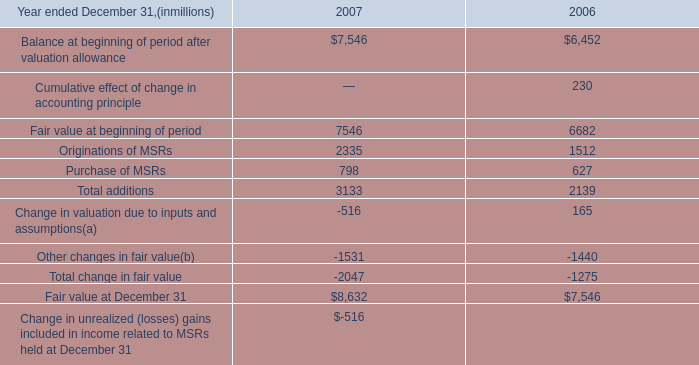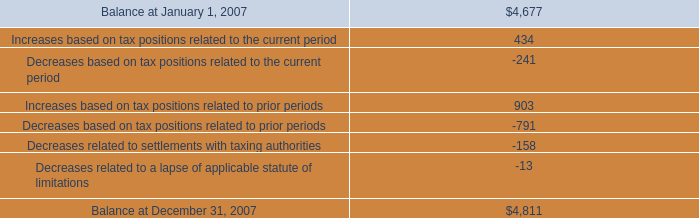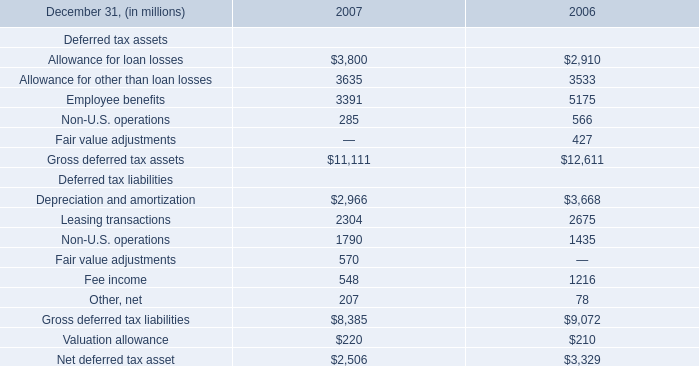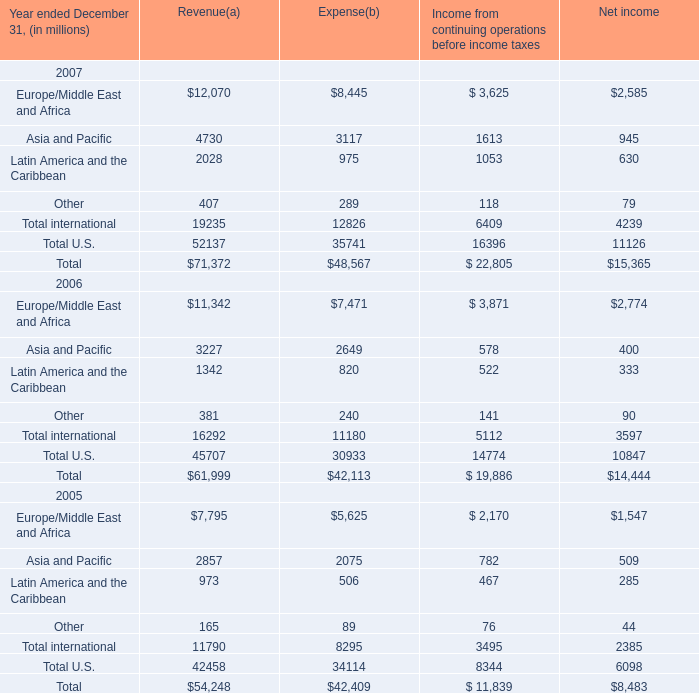What's the sum of Europe/Middle East and Africa 2005 of Net income, and Leasing transactions Deferred tax liabilities of 2007 ? 
Computations: (1547.0 + 2304.0)
Answer: 3851.0. 